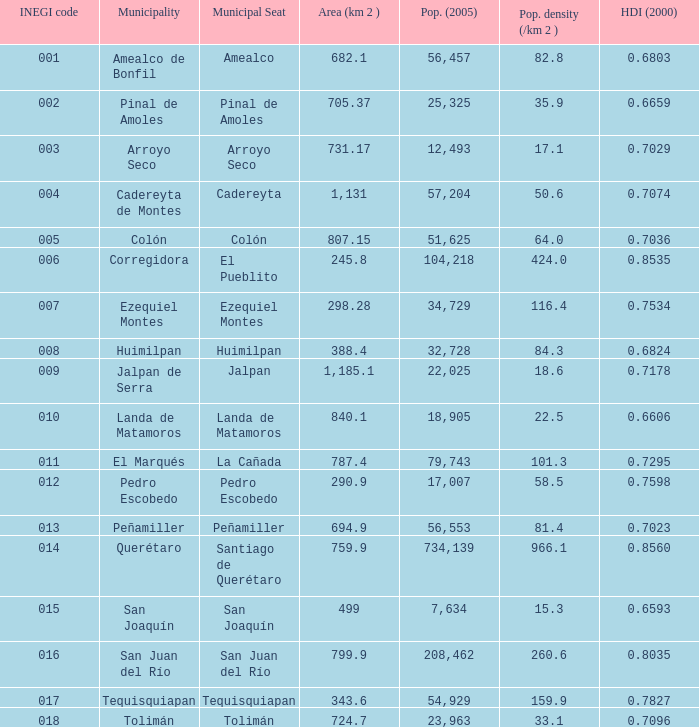WHat is the amount of Human Development Index (2000) that has a Population (2005) of 54,929, and an Area (km 2 ) larger than 343.6? 0.0. 